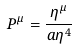<formula> <loc_0><loc_0><loc_500><loc_500>P ^ { \mu } = \frac { \eta ^ { \mu } } { a \eta ^ { 4 } }</formula> 